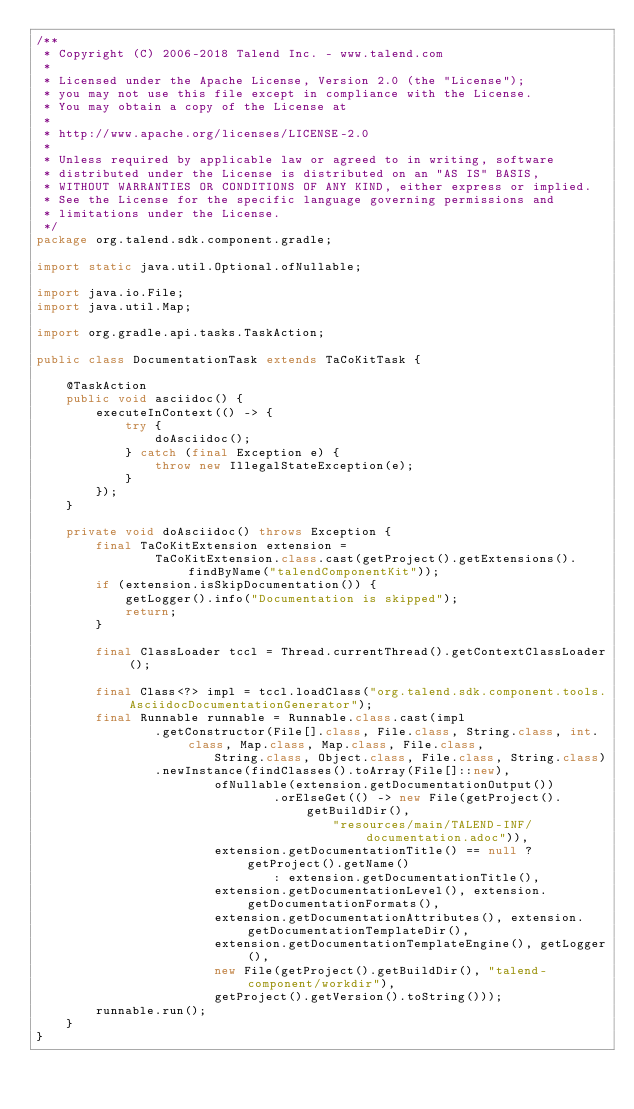<code> <loc_0><loc_0><loc_500><loc_500><_Java_>/**
 * Copyright (C) 2006-2018 Talend Inc. - www.talend.com
 *
 * Licensed under the Apache License, Version 2.0 (the "License");
 * you may not use this file except in compliance with the License.
 * You may obtain a copy of the License at
 *
 * http://www.apache.org/licenses/LICENSE-2.0
 *
 * Unless required by applicable law or agreed to in writing, software
 * distributed under the License is distributed on an "AS IS" BASIS,
 * WITHOUT WARRANTIES OR CONDITIONS OF ANY KIND, either express or implied.
 * See the License for the specific language governing permissions and
 * limitations under the License.
 */
package org.talend.sdk.component.gradle;

import static java.util.Optional.ofNullable;

import java.io.File;
import java.util.Map;

import org.gradle.api.tasks.TaskAction;

public class DocumentationTask extends TaCoKitTask {

    @TaskAction
    public void asciidoc() {
        executeInContext(() -> {
            try {
                doAsciidoc();
            } catch (final Exception e) {
                throw new IllegalStateException(e);
            }
        });
    }

    private void doAsciidoc() throws Exception {
        final TaCoKitExtension extension =
                TaCoKitExtension.class.cast(getProject().getExtensions().findByName("talendComponentKit"));
        if (extension.isSkipDocumentation()) {
            getLogger().info("Documentation is skipped");
            return;
        }

        final ClassLoader tccl = Thread.currentThread().getContextClassLoader();

        final Class<?> impl = tccl.loadClass("org.talend.sdk.component.tools.AsciidocDocumentationGenerator");
        final Runnable runnable = Runnable.class.cast(impl
                .getConstructor(File[].class, File.class, String.class, int.class, Map.class, Map.class, File.class,
                        String.class, Object.class, File.class, String.class)
                .newInstance(findClasses().toArray(File[]::new),
                        ofNullable(extension.getDocumentationOutput())
                                .orElseGet(() -> new File(getProject().getBuildDir(),
                                        "resources/main/TALEND-INF/documentation.adoc")),
                        extension.getDocumentationTitle() == null ? getProject().getName()
                                : extension.getDocumentationTitle(),
                        extension.getDocumentationLevel(), extension.getDocumentationFormats(),
                        extension.getDocumentationAttributes(), extension.getDocumentationTemplateDir(),
                        extension.getDocumentationTemplateEngine(), getLogger(),
                        new File(getProject().getBuildDir(), "talend-component/workdir"),
                        getProject().getVersion().toString()));
        runnable.run();
    }
}
</code> 